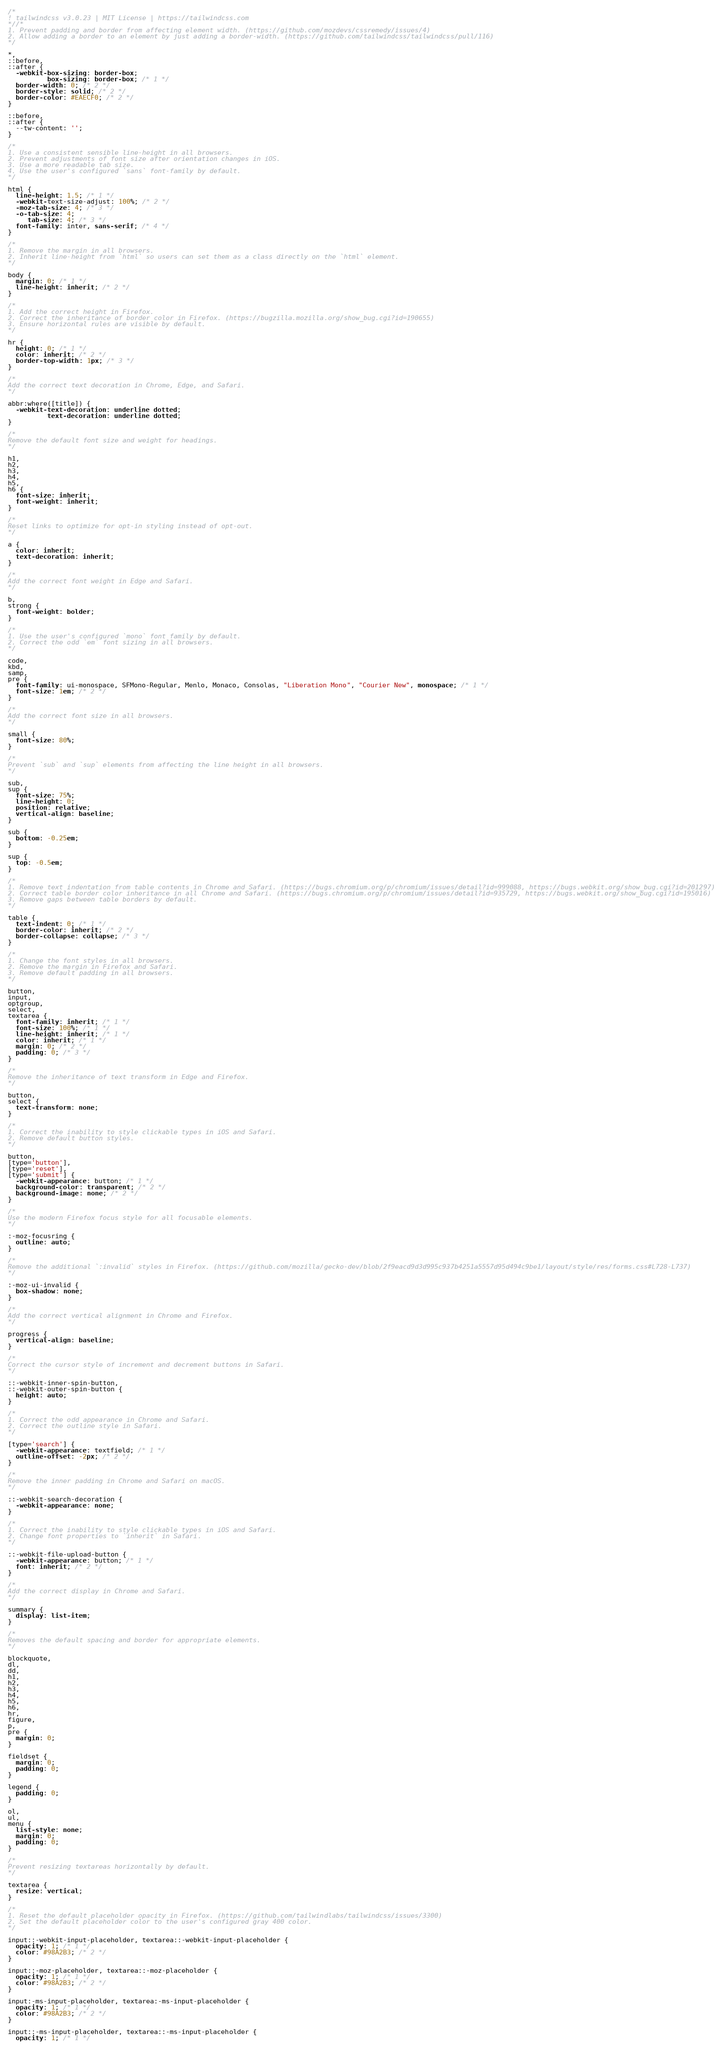<code> <loc_0><loc_0><loc_500><loc_500><_CSS_>/*
! tailwindcss v3.0.23 | MIT License | https://tailwindcss.com
*//*
1. Prevent padding and border from affecting element width. (https://github.com/mozdevs/cssremedy/issues/4)
2. Allow adding a border to an element by just adding a border-width. (https://github.com/tailwindcss/tailwindcss/pull/116)
*/

*,
::before,
::after {
  -webkit-box-sizing: border-box;
          box-sizing: border-box; /* 1 */
  border-width: 0; /* 2 */
  border-style: solid; /* 2 */
  border-color: #EAECF0; /* 2 */
}

::before,
::after {
  --tw-content: '';
}

/*
1. Use a consistent sensible line-height in all browsers.
2. Prevent adjustments of font size after orientation changes in iOS.
3. Use a more readable tab size.
4. Use the user's configured `sans` font-family by default.
*/

html {
  line-height: 1.5; /* 1 */
  -webkit-text-size-adjust: 100%; /* 2 */
  -moz-tab-size: 4; /* 3 */
  -o-tab-size: 4;
     tab-size: 4; /* 3 */
  font-family: inter, sans-serif; /* 4 */
}

/*
1. Remove the margin in all browsers.
2. Inherit line-height from `html` so users can set them as a class directly on the `html` element.
*/

body {
  margin: 0; /* 1 */
  line-height: inherit; /* 2 */
}

/*
1. Add the correct height in Firefox.
2. Correct the inheritance of border color in Firefox. (https://bugzilla.mozilla.org/show_bug.cgi?id=190655)
3. Ensure horizontal rules are visible by default.
*/

hr {
  height: 0; /* 1 */
  color: inherit; /* 2 */
  border-top-width: 1px; /* 3 */
}

/*
Add the correct text decoration in Chrome, Edge, and Safari.
*/

abbr:where([title]) {
  -webkit-text-decoration: underline dotted;
          text-decoration: underline dotted;
}

/*
Remove the default font size and weight for headings.
*/

h1,
h2,
h3,
h4,
h5,
h6 {
  font-size: inherit;
  font-weight: inherit;
}

/*
Reset links to optimize for opt-in styling instead of opt-out.
*/

a {
  color: inherit;
  text-decoration: inherit;
}

/*
Add the correct font weight in Edge and Safari.
*/

b,
strong {
  font-weight: bolder;
}

/*
1. Use the user's configured `mono` font family by default.
2. Correct the odd `em` font sizing in all browsers.
*/

code,
kbd,
samp,
pre {
  font-family: ui-monospace, SFMono-Regular, Menlo, Monaco, Consolas, "Liberation Mono", "Courier New", monospace; /* 1 */
  font-size: 1em; /* 2 */
}

/*
Add the correct font size in all browsers.
*/

small {
  font-size: 80%;
}

/*
Prevent `sub` and `sup` elements from affecting the line height in all browsers.
*/

sub,
sup {
  font-size: 75%;
  line-height: 0;
  position: relative;
  vertical-align: baseline;
}

sub {
  bottom: -0.25em;
}

sup {
  top: -0.5em;
}

/*
1. Remove text indentation from table contents in Chrome and Safari. (https://bugs.chromium.org/p/chromium/issues/detail?id=999088, https://bugs.webkit.org/show_bug.cgi?id=201297)
2. Correct table border color inheritance in all Chrome and Safari. (https://bugs.chromium.org/p/chromium/issues/detail?id=935729, https://bugs.webkit.org/show_bug.cgi?id=195016)
3. Remove gaps between table borders by default.
*/

table {
  text-indent: 0; /* 1 */
  border-color: inherit; /* 2 */
  border-collapse: collapse; /* 3 */
}

/*
1. Change the font styles in all browsers.
2. Remove the margin in Firefox and Safari.
3. Remove default padding in all browsers.
*/

button,
input,
optgroup,
select,
textarea {
  font-family: inherit; /* 1 */
  font-size: 100%; /* 1 */
  line-height: inherit; /* 1 */
  color: inherit; /* 1 */
  margin: 0; /* 2 */
  padding: 0; /* 3 */
}

/*
Remove the inheritance of text transform in Edge and Firefox.
*/

button,
select {
  text-transform: none;
}

/*
1. Correct the inability to style clickable types in iOS and Safari.
2. Remove default button styles.
*/

button,
[type='button'],
[type='reset'],
[type='submit'] {
  -webkit-appearance: button; /* 1 */
  background-color: transparent; /* 2 */
  background-image: none; /* 2 */
}

/*
Use the modern Firefox focus style for all focusable elements.
*/

:-moz-focusring {
  outline: auto;
}

/*
Remove the additional `:invalid` styles in Firefox. (https://github.com/mozilla/gecko-dev/blob/2f9eacd9d3d995c937b4251a5557d95d494c9be1/layout/style/res/forms.css#L728-L737)
*/

:-moz-ui-invalid {
  box-shadow: none;
}

/*
Add the correct vertical alignment in Chrome and Firefox.
*/

progress {
  vertical-align: baseline;
}

/*
Correct the cursor style of increment and decrement buttons in Safari.
*/

::-webkit-inner-spin-button,
::-webkit-outer-spin-button {
  height: auto;
}

/*
1. Correct the odd appearance in Chrome and Safari.
2. Correct the outline style in Safari.
*/

[type='search'] {
  -webkit-appearance: textfield; /* 1 */
  outline-offset: -2px; /* 2 */
}

/*
Remove the inner padding in Chrome and Safari on macOS.
*/

::-webkit-search-decoration {
  -webkit-appearance: none;
}

/*
1. Correct the inability to style clickable types in iOS and Safari.
2. Change font properties to `inherit` in Safari.
*/

::-webkit-file-upload-button {
  -webkit-appearance: button; /* 1 */
  font: inherit; /* 2 */
}

/*
Add the correct display in Chrome and Safari.
*/

summary {
  display: list-item;
}

/*
Removes the default spacing and border for appropriate elements.
*/

blockquote,
dl,
dd,
h1,
h2,
h3,
h4,
h5,
h6,
hr,
figure,
p,
pre {
  margin: 0;
}

fieldset {
  margin: 0;
  padding: 0;
}

legend {
  padding: 0;
}

ol,
ul,
menu {
  list-style: none;
  margin: 0;
  padding: 0;
}

/*
Prevent resizing textareas horizontally by default.
*/

textarea {
  resize: vertical;
}

/*
1. Reset the default placeholder opacity in Firefox. (https://github.com/tailwindlabs/tailwindcss/issues/3300)
2. Set the default placeholder color to the user's configured gray 400 color.
*/

input::-webkit-input-placeholder, textarea::-webkit-input-placeholder {
  opacity: 1; /* 1 */
  color: #98A2B3; /* 2 */
}

input::-moz-placeholder, textarea::-moz-placeholder {
  opacity: 1; /* 1 */
  color: #98A2B3; /* 2 */
}

input:-ms-input-placeholder, textarea:-ms-input-placeholder {
  opacity: 1; /* 1 */
  color: #98A2B3; /* 2 */
}

input::-ms-input-placeholder, textarea::-ms-input-placeholder {
  opacity: 1; /* 1 */</code> 